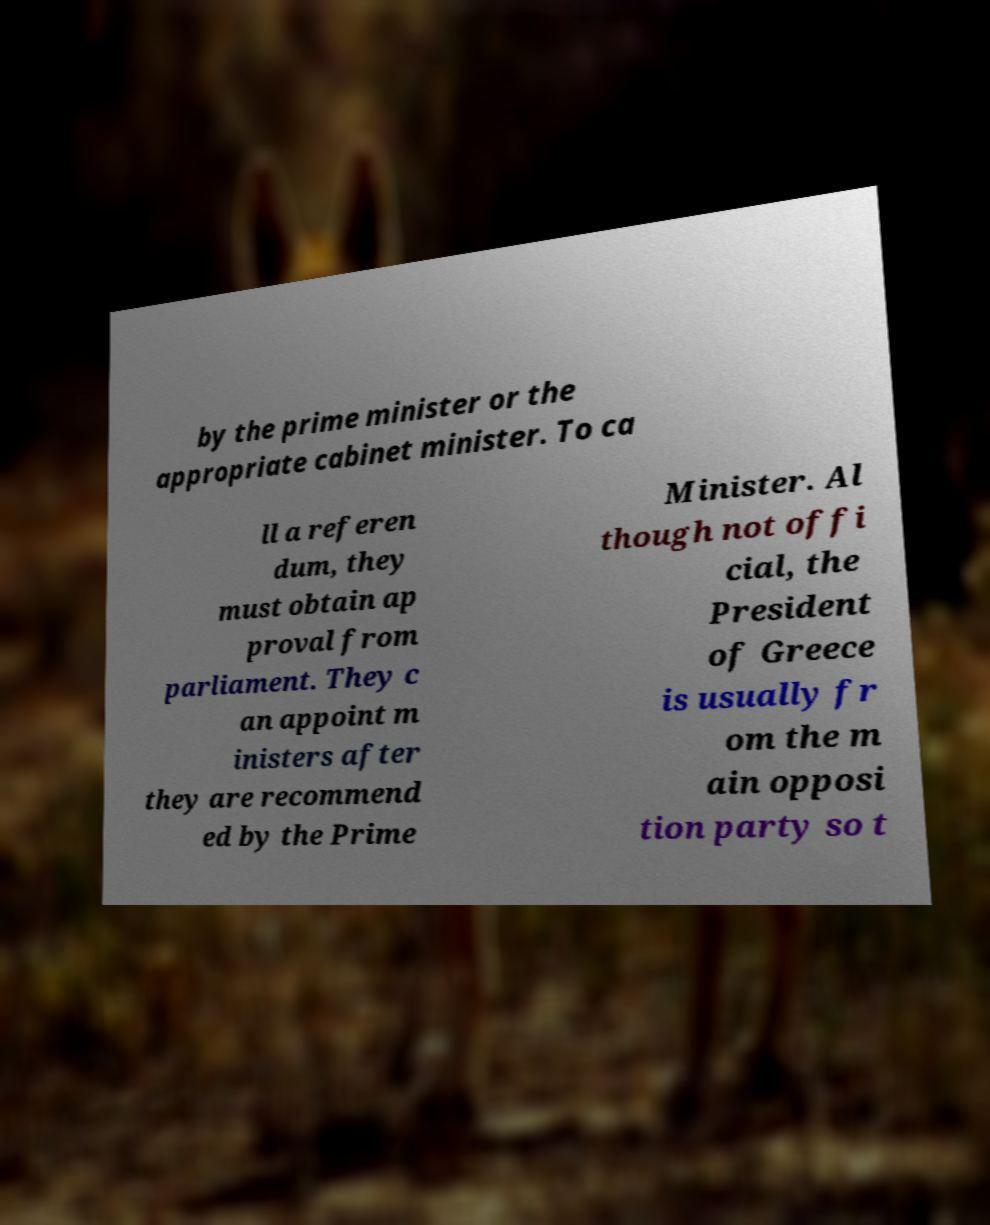Can you read and provide the text displayed in the image?This photo seems to have some interesting text. Can you extract and type it out for me? by the prime minister or the appropriate cabinet minister. To ca ll a referen dum, they must obtain ap proval from parliament. They c an appoint m inisters after they are recommend ed by the Prime Minister. Al though not offi cial, the President of Greece is usually fr om the m ain opposi tion party so t 